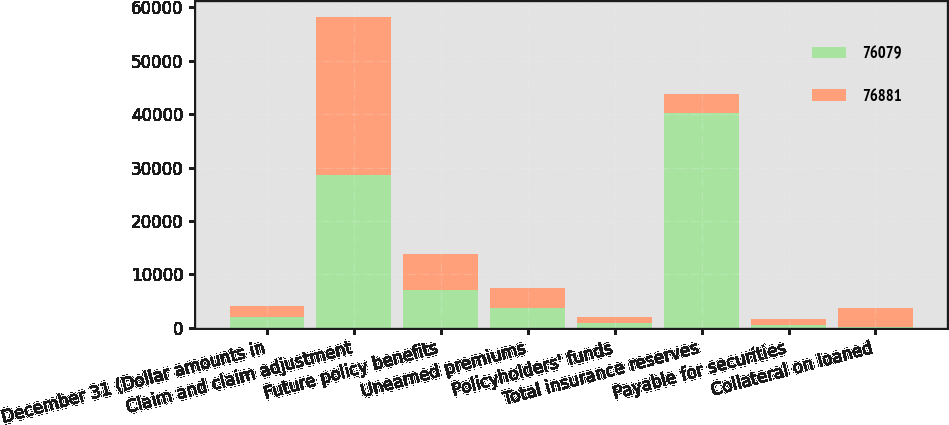<chart> <loc_0><loc_0><loc_500><loc_500><stacked_bar_chart><ecel><fcel>December 31 (Dollar amounts in<fcel>Claim and claim adjustment<fcel>Future policy benefits<fcel>Unearned premiums<fcel>Policyholders' funds<fcel>Total insurance reserves<fcel>Payable for securities<fcel>Collateral on loaned<nl><fcel>76079<fcel>2007<fcel>28588<fcel>7106<fcel>3597<fcel>930<fcel>40221<fcel>544<fcel>63<nl><fcel>76881<fcel>2006<fcel>29636<fcel>6645<fcel>3784<fcel>1015<fcel>3597<fcel>1047<fcel>3602<nl></chart> 